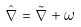<formula> <loc_0><loc_0><loc_500><loc_500>\hat { \nabla } = \tilde { \nabla } + \omega</formula> 